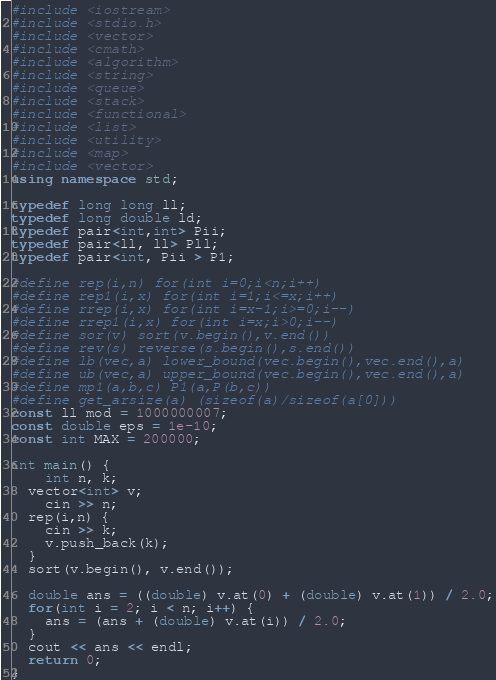<code> <loc_0><loc_0><loc_500><loc_500><_C++_>#include <iostream>
#include <stdio.h>
#include <vector>
#include <cmath>
#include <algorithm>
#include <string>
#include <queue>
#include <stack>
#include <functional>
#include <list>
#include <utility>
#include <map>
#include <vector>
using namespace std;

typedef long long ll;
typedef long double ld;
typedef pair<int,int> Pii;
typedef pair<ll, ll> Pll;
typedef pair<int, Pii > P1;

#define rep(i,n) for(int i=0;i<n;i++)
#define rep1(i,x) for(int i=1;i<=x;i++)
#define rrep(i,x) for(int i=x-1;i>=0;i--)
#define rrep1(i,x) for(int i=x;i>0;i--)
#define sor(v) sort(v.begin(),v.end())
#define rev(s) reverse(s.begin(),s.end())
#define lb(vec,a) lower_bound(vec.begin(),vec.end(),a)
#define ub(vec,a) upper_bound(vec.begin(),vec.end(),a)
#define mp1(a,b,c) P1(a,P(b,c))
#define get_arsize(a) (sizeof(a)/sizeof(a[0]))
const ll mod = 1000000007;
const double eps = 1e-10;
const int MAX = 200000;

int main() {
	int n, k;
  vector<int> v;
	cin >> n;
  rep(i,n) {
    cin >> k;
    v.push_back(k);
  }
  sort(v.begin(), v.end());

  double ans = ((double) v.at(0) + (double) v.at(1)) / 2.0;
  for(int i = 2; i < n; i++) {
    ans = (ans + (double) v.at(i)) / 2.0;
  }
  cout << ans << endl;
  return 0;
}</code> 